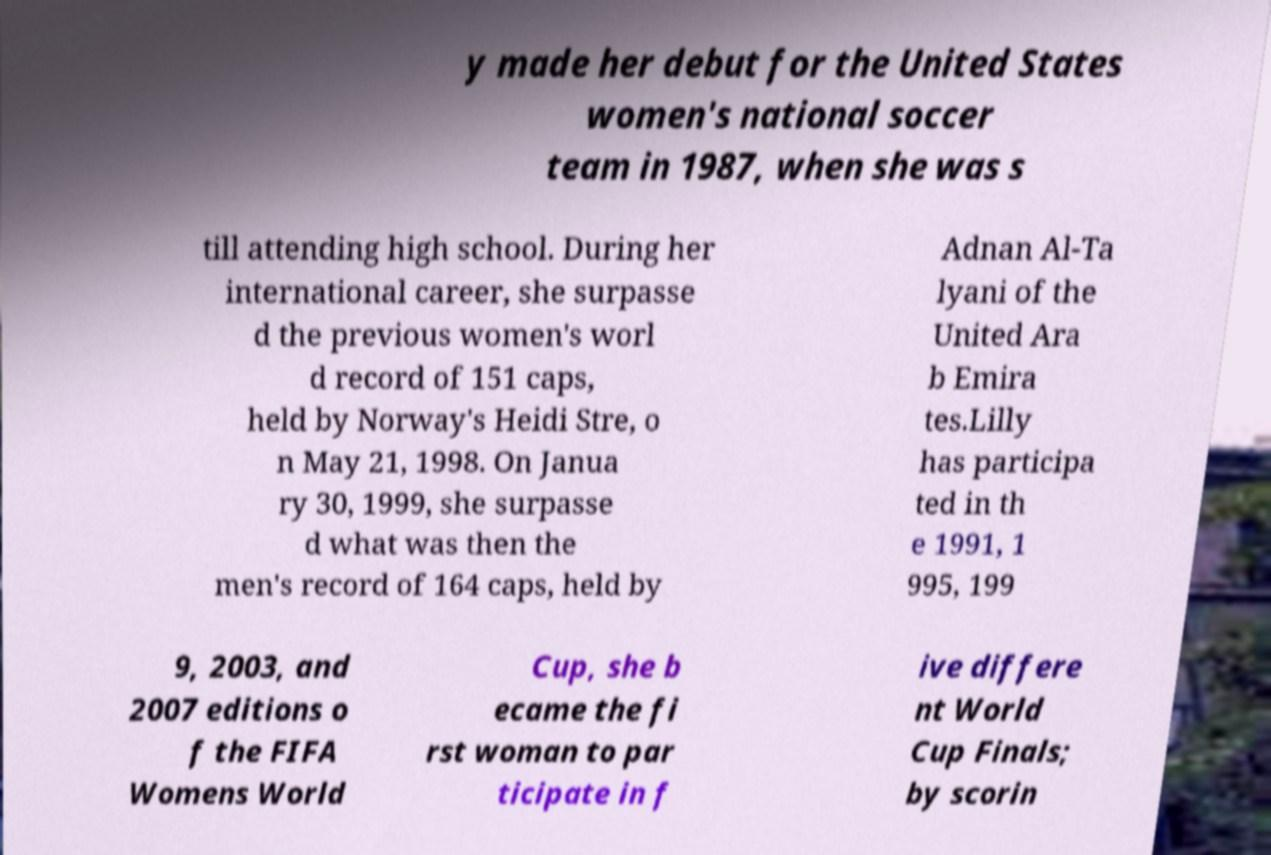Could you assist in decoding the text presented in this image and type it out clearly? y made her debut for the United States women's national soccer team in 1987, when she was s till attending high school. During her international career, she surpasse d the previous women's worl d record of 151 caps, held by Norway's Heidi Stre, o n May 21, 1998. On Janua ry 30, 1999, she surpasse d what was then the men's record of 164 caps, held by Adnan Al-Ta lyani of the United Ara b Emira tes.Lilly has participa ted in th e 1991, 1 995, 199 9, 2003, and 2007 editions o f the FIFA Womens World Cup, she b ecame the fi rst woman to par ticipate in f ive differe nt World Cup Finals; by scorin 